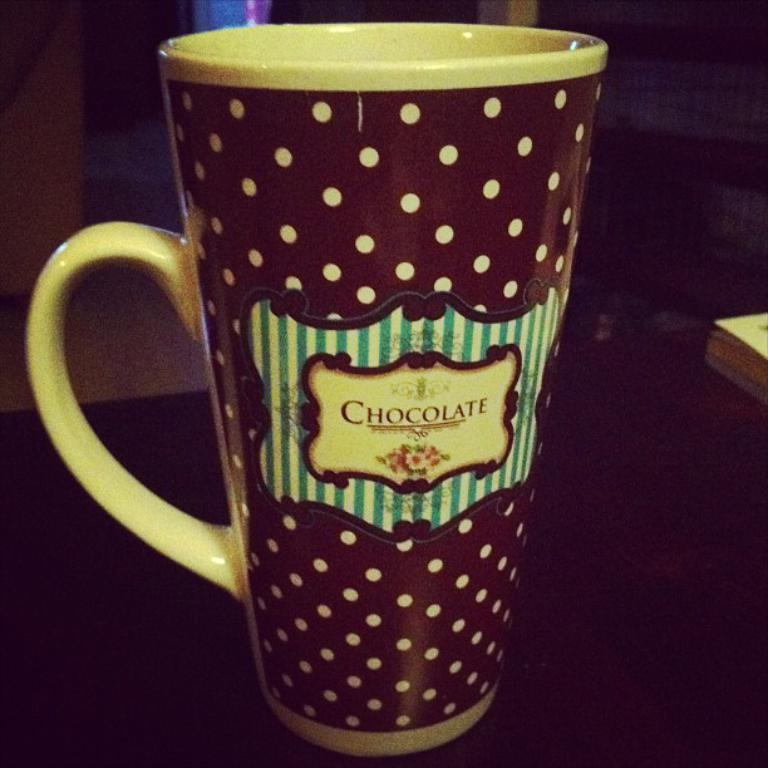<image>
Give a short and clear explanation of the subsequent image. a brown polka dot mug reading Chocolate on a table 